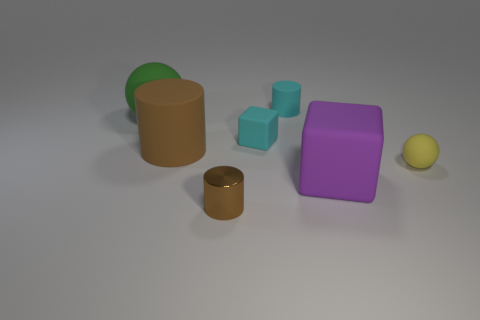There is a green matte object that is behind the matte cylinder that is left of the small shiny thing; how big is it?
Your response must be concise. Large. What size is the object that is both behind the small cube and right of the big green matte thing?
Offer a very short reply. Small. How many cyan rubber cylinders have the same size as the brown metallic object?
Your answer should be very brief. 1. How many matte objects are tiny blocks or large green balls?
Ensure brevity in your answer.  2. There is a object that is the same color as the metal cylinder; what size is it?
Offer a very short reply. Large. There is a ball that is right of the brown cylinder in front of the small yellow thing; what is it made of?
Make the answer very short. Rubber. How many objects are purple matte things or brown cylinders that are behind the yellow object?
Keep it short and to the point. 2. There is a yellow object that is made of the same material as the small cyan cylinder; what is its size?
Offer a very short reply. Small. How many purple objects are big matte blocks or large metal cubes?
Provide a short and direct response. 1. What shape is the tiny matte thing that is the same color as the small matte cylinder?
Your response must be concise. Cube. 